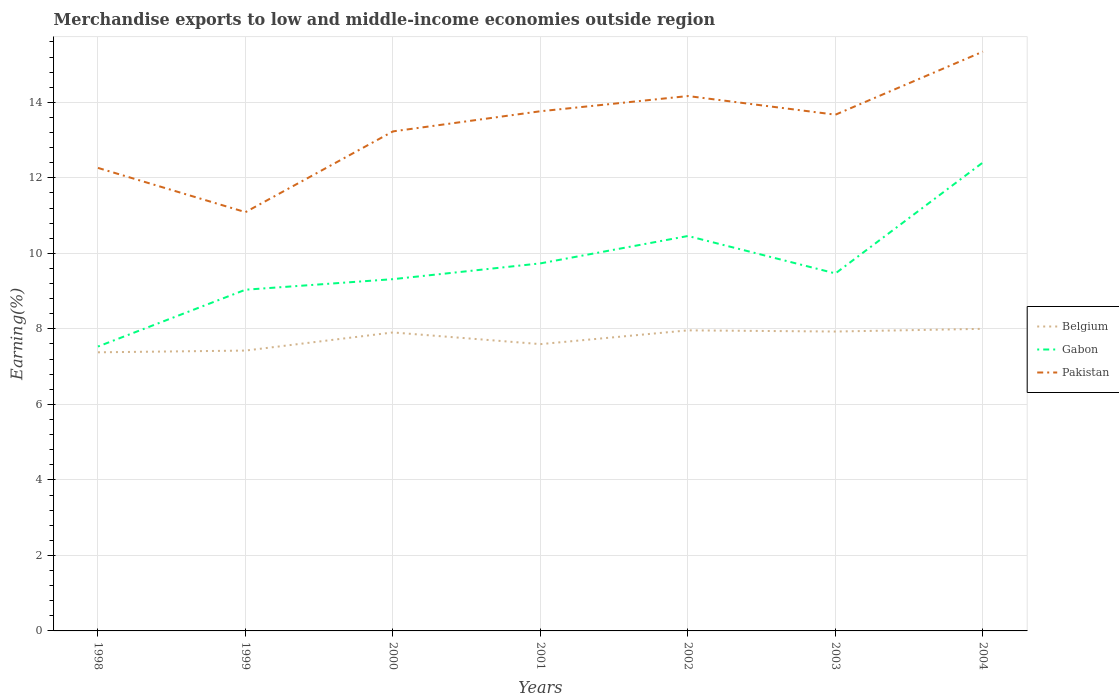Across all years, what is the maximum percentage of amount earned from merchandise exports in Gabon?
Your response must be concise. 7.53. What is the total percentage of amount earned from merchandise exports in Gabon in the graph?
Your response must be concise. -1.5. What is the difference between the highest and the second highest percentage of amount earned from merchandise exports in Belgium?
Your answer should be compact. 0.62. What is the difference between the highest and the lowest percentage of amount earned from merchandise exports in Gabon?
Ensure brevity in your answer.  3. How many lines are there?
Give a very brief answer. 3. What is the difference between two consecutive major ticks on the Y-axis?
Ensure brevity in your answer.  2. Does the graph contain any zero values?
Make the answer very short. No. Does the graph contain grids?
Provide a short and direct response. Yes. Where does the legend appear in the graph?
Provide a succinct answer. Center right. What is the title of the graph?
Keep it short and to the point. Merchandise exports to low and middle-income economies outside region. What is the label or title of the Y-axis?
Offer a terse response. Earning(%). What is the Earning(%) of Belgium in 1998?
Make the answer very short. 7.38. What is the Earning(%) in Gabon in 1998?
Offer a terse response. 7.53. What is the Earning(%) of Pakistan in 1998?
Your response must be concise. 12.26. What is the Earning(%) in Belgium in 1999?
Provide a short and direct response. 7.43. What is the Earning(%) in Gabon in 1999?
Your answer should be compact. 9.04. What is the Earning(%) in Pakistan in 1999?
Offer a terse response. 11.09. What is the Earning(%) in Belgium in 2000?
Make the answer very short. 7.91. What is the Earning(%) in Gabon in 2000?
Provide a short and direct response. 9.32. What is the Earning(%) of Pakistan in 2000?
Keep it short and to the point. 13.23. What is the Earning(%) in Belgium in 2001?
Your response must be concise. 7.6. What is the Earning(%) in Gabon in 2001?
Give a very brief answer. 9.74. What is the Earning(%) of Pakistan in 2001?
Offer a very short reply. 13.76. What is the Earning(%) of Belgium in 2002?
Offer a terse response. 7.96. What is the Earning(%) in Gabon in 2002?
Your answer should be very brief. 10.46. What is the Earning(%) of Pakistan in 2002?
Ensure brevity in your answer.  14.17. What is the Earning(%) of Belgium in 2003?
Your answer should be very brief. 7.93. What is the Earning(%) in Gabon in 2003?
Provide a short and direct response. 9.47. What is the Earning(%) of Pakistan in 2003?
Provide a succinct answer. 13.67. What is the Earning(%) in Belgium in 2004?
Offer a terse response. 8. What is the Earning(%) in Gabon in 2004?
Offer a very short reply. 12.41. What is the Earning(%) of Pakistan in 2004?
Ensure brevity in your answer.  15.34. Across all years, what is the maximum Earning(%) of Belgium?
Provide a succinct answer. 8. Across all years, what is the maximum Earning(%) in Gabon?
Keep it short and to the point. 12.41. Across all years, what is the maximum Earning(%) in Pakistan?
Make the answer very short. 15.34. Across all years, what is the minimum Earning(%) of Belgium?
Offer a terse response. 7.38. Across all years, what is the minimum Earning(%) in Gabon?
Your response must be concise. 7.53. Across all years, what is the minimum Earning(%) of Pakistan?
Your response must be concise. 11.09. What is the total Earning(%) of Belgium in the graph?
Keep it short and to the point. 54.2. What is the total Earning(%) in Gabon in the graph?
Offer a terse response. 67.96. What is the total Earning(%) of Pakistan in the graph?
Keep it short and to the point. 93.54. What is the difference between the Earning(%) in Belgium in 1998 and that in 1999?
Offer a terse response. -0.05. What is the difference between the Earning(%) of Gabon in 1998 and that in 1999?
Keep it short and to the point. -1.5. What is the difference between the Earning(%) in Pakistan in 1998 and that in 1999?
Your answer should be very brief. 1.17. What is the difference between the Earning(%) in Belgium in 1998 and that in 2000?
Give a very brief answer. -0.53. What is the difference between the Earning(%) in Gabon in 1998 and that in 2000?
Offer a very short reply. -1.78. What is the difference between the Earning(%) in Pakistan in 1998 and that in 2000?
Give a very brief answer. -0.97. What is the difference between the Earning(%) in Belgium in 1998 and that in 2001?
Offer a terse response. -0.22. What is the difference between the Earning(%) in Gabon in 1998 and that in 2001?
Offer a terse response. -2.2. What is the difference between the Earning(%) of Pakistan in 1998 and that in 2001?
Offer a terse response. -1.5. What is the difference between the Earning(%) in Belgium in 1998 and that in 2002?
Keep it short and to the point. -0.58. What is the difference between the Earning(%) of Gabon in 1998 and that in 2002?
Your answer should be compact. -2.93. What is the difference between the Earning(%) of Pakistan in 1998 and that in 2002?
Make the answer very short. -1.9. What is the difference between the Earning(%) in Belgium in 1998 and that in 2003?
Give a very brief answer. -0.55. What is the difference between the Earning(%) of Gabon in 1998 and that in 2003?
Give a very brief answer. -1.94. What is the difference between the Earning(%) of Pakistan in 1998 and that in 2003?
Your answer should be very brief. -1.41. What is the difference between the Earning(%) of Belgium in 1998 and that in 2004?
Your answer should be very brief. -0.62. What is the difference between the Earning(%) of Gabon in 1998 and that in 2004?
Provide a short and direct response. -4.88. What is the difference between the Earning(%) of Pakistan in 1998 and that in 2004?
Provide a succinct answer. -3.08. What is the difference between the Earning(%) of Belgium in 1999 and that in 2000?
Make the answer very short. -0.48. What is the difference between the Earning(%) of Gabon in 1999 and that in 2000?
Offer a terse response. -0.28. What is the difference between the Earning(%) in Pakistan in 1999 and that in 2000?
Give a very brief answer. -2.14. What is the difference between the Earning(%) in Belgium in 1999 and that in 2001?
Your response must be concise. -0.17. What is the difference between the Earning(%) of Gabon in 1999 and that in 2001?
Offer a very short reply. -0.7. What is the difference between the Earning(%) in Pakistan in 1999 and that in 2001?
Your answer should be very brief. -2.67. What is the difference between the Earning(%) of Belgium in 1999 and that in 2002?
Offer a very short reply. -0.54. What is the difference between the Earning(%) in Gabon in 1999 and that in 2002?
Your answer should be compact. -1.42. What is the difference between the Earning(%) in Pakistan in 1999 and that in 2002?
Your response must be concise. -3.08. What is the difference between the Earning(%) in Belgium in 1999 and that in 2003?
Provide a short and direct response. -0.5. What is the difference between the Earning(%) in Gabon in 1999 and that in 2003?
Give a very brief answer. -0.43. What is the difference between the Earning(%) of Pakistan in 1999 and that in 2003?
Your answer should be compact. -2.58. What is the difference between the Earning(%) of Belgium in 1999 and that in 2004?
Keep it short and to the point. -0.58. What is the difference between the Earning(%) in Gabon in 1999 and that in 2004?
Ensure brevity in your answer.  -3.37. What is the difference between the Earning(%) of Pakistan in 1999 and that in 2004?
Your answer should be compact. -4.25. What is the difference between the Earning(%) in Belgium in 2000 and that in 2001?
Give a very brief answer. 0.31. What is the difference between the Earning(%) of Gabon in 2000 and that in 2001?
Your answer should be compact. -0.42. What is the difference between the Earning(%) of Pakistan in 2000 and that in 2001?
Make the answer very short. -0.53. What is the difference between the Earning(%) in Belgium in 2000 and that in 2002?
Offer a terse response. -0.06. What is the difference between the Earning(%) of Gabon in 2000 and that in 2002?
Provide a short and direct response. -1.14. What is the difference between the Earning(%) in Pakistan in 2000 and that in 2002?
Your answer should be very brief. -0.94. What is the difference between the Earning(%) of Belgium in 2000 and that in 2003?
Offer a terse response. -0.02. What is the difference between the Earning(%) of Gabon in 2000 and that in 2003?
Provide a succinct answer. -0.15. What is the difference between the Earning(%) of Pakistan in 2000 and that in 2003?
Keep it short and to the point. -0.44. What is the difference between the Earning(%) of Belgium in 2000 and that in 2004?
Your response must be concise. -0.1. What is the difference between the Earning(%) in Gabon in 2000 and that in 2004?
Give a very brief answer. -3.09. What is the difference between the Earning(%) in Pakistan in 2000 and that in 2004?
Make the answer very short. -2.11. What is the difference between the Earning(%) of Belgium in 2001 and that in 2002?
Make the answer very short. -0.36. What is the difference between the Earning(%) of Gabon in 2001 and that in 2002?
Your response must be concise. -0.73. What is the difference between the Earning(%) of Pakistan in 2001 and that in 2002?
Your answer should be compact. -0.4. What is the difference between the Earning(%) of Belgium in 2001 and that in 2003?
Offer a terse response. -0.33. What is the difference between the Earning(%) of Gabon in 2001 and that in 2003?
Provide a succinct answer. 0.27. What is the difference between the Earning(%) in Pakistan in 2001 and that in 2003?
Provide a succinct answer. 0.09. What is the difference between the Earning(%) in Belgium in 2001 and that in 2004?
Provide a succinct answer. -0.41. What is the difference between the Earning(%) in Gabon in 2001 and that in 2004?
Your answer should be very brief. -2.67. What is the difference between the Earning(%) of Pakistan in 2001 and that in 2004?
Make the answer very short. -1.58. What is the difference between the Earning(%) in Belgium in 2002 and that in 2003?
Your response must be concise. 0.03. What is the difference between the Earning(%) of Pakistan in 2002 and that in 2003?
Your answer should be very brief. 0.49. What is the difference between the Earning(%) of Belgium in 2002 and that in 2004?
Provide a short and direct response. -0.04. What is the difference between the Earning(%) of Gabon in 2002 and that in 2004?
Your answer should be very brief. -1.95. What is the difference between the Earning(%) of Pakistan in 2002 and that in 2004?
Provide a short and direct response. -1.18. What is the difference between the Earning(%) in Belgium in 2003 and that in 2004?
Your answer should be very brief. -0.07. What is the difference between the Earning(%) of Gabon in 2003 and that in 2004?
Keep it short and to the point. -2.94. What is the difference between the Earning(%) in Pakistan in 2003 and that in 2004?
Provide a short and direct response. -1.67. What is the difference between the Earning(%) in Belgium in 1998 and the Earning(%) in Gabon in 1999?
Your response must be concise. -1.66. What is the difference between the Earning(%) of Belgium in 1998 and the Earning(%) of Pakistan in 1999?
Your answer should be compact. -3.71. What is the difference between the Earning(%) in Gabon in 1998 and the Earning(%) in Pakistan in 1999?
Provide a short and direct response. -3.56. What is the difference between the Earning(%) in Belgium in 1998 and the Earning(%) in Gabon in 2000?
Provide a succinct answer. -1.94. What is the difference between the Earning(%) of Belgium in 1998 and the Earning(%) of Pakistan in 2000?
Provide a succinct answer. -5.85. What is the difference between the Earning(%) in Gabon in 1998 and the Earning(%) in Pakistan in 2000?
Offer a terse response. -5.7. What is the difference between the Earning(%) of Belgium in 1998 and the Earning(%) of Gabon in 2001?
Make the answer very short. -2.36. What is the difference between the Earning(%) of Belgium in 1998 and the Earning(%) of Pakistan in 2001?
Your response must be concise. -6.38. What is the difference between the Earning(%) of Gabon in 1998 and the Earning(%) of Pakistan in 2001?
Your answer should be very brief. -6.23. What is the difference between the Earning(%) of Belgium in 1998 and the Earning(%) of Gabon in 2002?
Provide a short and direct response. -3.08. What is the difference between the Earning(%) of Belgium in 1998 and the Earning(%) of Pakistan in 2002?
Offer a terse response. -6.79. What is the difference between the Earning(%) in Gabon in 1998 and the Earning(%) in Pakistan in 2002?
Provide a succinct answer. -6.63. What is the difference between the Earning(%) of Belgium in 1998 and the Earning(%) of Gabon in 2003?
Keep it short and to the point. -2.09. What is the difference between the Earning(%) of Belgium in 1998 and the Earning(%) of Pakistan in 2003?
Provide a succinct answer. -6.29. What is the difference between the Earning(%) in Gabon in 1998 and the Earning(%) in Pakistan in 2003?
Offer a very short reply. -6.14. What is the difference between the Earning(%) in Belgium in 1998 and the Earning(%) in Gabon in 2004?
Provide a succinct answer. -5.03. What is the difference between the Earning(%) of Belgium in 1998 and the Earning(%) of Pakistan in 2004?
Your answer should be very brief. -7.96. What is the difference between the Earning(%) of Gabon in 1998 and the Earning(%) of Pakistan in 2004?
Offer a very short reply. -7.81. What is the difference between the Earning(%) in Belgium in 1999 and the Earning(%) in Gabon in 2000?
Give a very brief answer. -1.89. What is the difference between the Earning(%) in Belgium in 1999 and the Earning(%) in Pakistan in 2000?
Give a very brief answer. -5.81. What is the difference between the Earning(%) of Gabon in 1999 and the Earning(%) of Pakistan in 2000?
Your answer should be compact. -4.19. What is the difference between the Earning(%) in Belgium in 1999 and the Earning(%) in Gabon in 2001?
Your response must be concise. -2.31. What is the difference between the Earning(%) of Belgium in 1999 and the Earning(%) of Pakistan in 2001?
Your response must be concise. -6.34. What is the difference between the Earning(%) of Gabon in 1999 and the Earning(%) of Pakistan in 2001?
Offer a terse response. -4.73. What is the difference between the Earning(%) of Belgium in 1999 and the Earning(%) of Gabon in 2002?
Your answer should be compact. -3.04. What is the difference between the Earning(%) in Belgium in 1999 and the Earning(%) in Pakistan in 2002?
Offer a terse response. -6.74. What is the difference between the Earning(%) in Gabon in 1999 and the Earning(%) in Pakistan in 2002?
Your response must be concise. -5.13. What is the difference between the Earning(%) of Belgium in 1999 and the Earning(%) of Gabon in 2003?
Your response must be concise. -2.04. What is the difference between the Earning(%) in Belgium in 1999 and the Earning(%) in Pakistan in 2003?
Ensure brevity in your answer.  -6.25. What is the difference between the Earning(%) of Gabon in 1999 and the Earning(%) of Pakistan in 2003?
Give a very brief answer. -4.64. What is the difference between the Earning(%) of Belgium in 1999 and the Earning(%) of Gabon in 2004?
Provide a short and direct response. -4.98. What is the difference between the Earning(%) in Belgium in 1999 and the Earning(%) in Pakistan in 2004?
Provide a short and direct response. -7.92. What is the difference between the Earning(%) in Gabon in 1999 and the Earning(%) in Pakistan in 2004?
Ensure brevity in your answer.  -6.31. What is the difference between the Earning(%) of Belgium in 2000 and the Earning(%) of Gabon in 2001?
Offer a very short reply. -1.83. What is the difference between the Earning(%) in Belgium in 2000 and the Earning(%) in Pakistan in 2001?
Your answer should be compact. -5.86. What is the difference between the Earning(%) in Gabon in 2000 and the Earning(%) in Pakistan in 2001?
Ensure brevity in your answer.  -4.45. What is the difference between the Earning(%) in Belgium in 2000 and the Earning(%) in Gabon in 2002?
Offer a very short reply. -2.55. What is the difference between the Earning(%) of Belgium in 2000 and the Earning(%) of Pakistan in 2002?
Provide a short and direct response. -6.26. What is the difference between the Earning(%) in Gabon in 2000 and the Earning(%) in Pakistan in 2002?
Your answer should be compact. -4.85. What is the difference between the Earning(%) of Belgium in 2000 and the Earning(%) of Gabon in 2003?
Provide a succinct answer. -1.56. What is the difference between the Earning(%) of Belgium in 2000 and the Earning(%) of Pakistan in 2003?
Ensure brevity in your answer.  -5.77. What is the difference between the Earning(%) of Gabon in 2000 and the Earning(%) of Pakistan in 2003?
Provide a succinct answer. -4.36. What is the difference between the Earning(%) of Belgium in 2000 and the Earning(%) of Gabon in 2004?
Provide a succinct answer. -4.5. What is the difference between the Earning(%) in Belgium in 2000 and the Earning(%) in Pakistan in 2004?
Offer a very short reply. -7.44. What is the difference between the Earning(%) in Gabon in 2000 and the Earning(%) in Pakistan in 2004?
Offer a very short reply. -6.03. What is the difference between the Earning(%) of Belgium in 2001 and the Earning(%) of Gabon in 2002?
Make the answer very short. -2.86. What is the difference between the Earning(%) in Belgium in 2001 and the Earning(%) in Pakistan in 2002?
Provide a short and direct response. -6.57. What is the difference between the Earning(%) of Gabon in 2001 and the Earning(%) of Pakistan in 2002?
Your answer should be very brief. -4.43. What is the difference between the Earning(%) of Belgium in 2001 and the Earning(%) of Gabon in 2003?
Offer a very short reply. -1.87. What is the difference between the Earning(%) in Belgium in 2001 and the Earning(%) in Pakistan in 2003?
Give a very brief answer. -6.08. What is the difference between the Earning(%) in Gabon in 2001 and the Earning(%) in Pakistan in 2003?
Provide a succinct answer. -3.94. What is the difference between the Earning(%) in Belgium in 2001 and the Earning(%) in Gabon in 2004?
Your response must be concise. -4.81. What is the difference between the Earning(%) of Belgium in 2001 and the Earning(%) of Pakistan in 2004?
Make the answer very short. -7.75. What is the difference between the Earning(%) of Gabon in 2001 and the Earning(%) of Pakistan in 2004?
Your answer should be compact. -5.61. What is the difference between the Earning(%) in Belgium in 2002 and the Earning(%) in Gabon in 2003?
Offer a very short reply. -1.51. What is the difference between the Earning(%) of Belgium in 2002 and the Earning(%) of Pakistan in 2003?
Offer a terse response. -5.71. What is the difference between the Earning(%) of Gabon in 2002 and the Earning(%) of Pakistan in 2003?
Give a very brief answer. -3.21. What is the difference between the Earning(%) in Belgium in 2002 and the Earning(%) in Gabon in 2004?
Provide a succinct answer. -4.45. What is the difference between the Earning(%) of Belgium in 2002 and the Earning(%) of Pakistan in 2004?
Give a very brief answer. -7.38. What is the difference between the Earning(%) in Gabon in 2002 and the Earning(%) in Pakistan in 2004?
Offer a terse response. -4.88. What is the difference between the Earning(%) in Belgium in 2003 and the Earning(%) in Gabon in 2004?
Make the answer very short. -4.48. What is the difference between the Earning(%) in Belgium in 2003 and the Earning(%) in Pakistan in 2004?
Offer a terse response. -7.41. What is the difference between the Earning(%) of Gabon in 2003 and the Earning(%) of Pakistan in 2004?
Give a very brief answer. -5.88. What is the average Earning(%) of Belgium per year?
Make the answer very short. 7.74. What is the average Earning(%) of Gabon per year?
Your response must be concise. 9.71. What is the average Earning(%) of Pakistan per year?
Your answer should be very brief. 13.36. In the year 1998, what is the difference between the Earning(%) in Belgium and Earning(%) in Gabon?
Your response must be concise. -0.15. In the year 1998, what is the difference between the Earning(%) in Belgium and Earning(%) in Pakistan?
Your answer should be very brief. -4.88. In the year 1998, what is the difference between the Earning(%) in Gabon and Earning(%) in Pakistan?
Keep it short and to the point. -4.73. In the year 1999, what is the difference between the Earning(%) of Belgium and Earning(%) of Gabon?
Make the answer very short. -1.61. In the year 1999, what is the difference between the Earning(%) in Belgium and Earning(%) in Pakistan?
Give a very brief answer. -3.67. In the year 1999, what is the difference between the Earning(%) of Gabon and Earning(%) of Pakistan?
Offer a very short reply. -2.05. In the year 2000, what is the difference between the Earning(%) of Belgium and Earning(%) of Gabon?
Your response must be concise. -1.41. In the year 2000, what is the difference between the Earning(%) of Belgium and Earning(%) of Pakistan?
Your response must be concise. -5.33. In the year 2000, what is the difference between the Earning(%) of Gabon and Earning(%) of Pakistan?
Give a very brief answer. -3.91. In the year 2001, what is the difference between the Earning(%) in Belgium and Earning(%) in Gabon?
Provide a short and direct response. -2.14. In the year 2001, what is the difference between the Earning(%) in Belgium and Earning(%) in Pakistan?
Make the answer very short. -6.17. In the year 2001, what is the difference between the Earning(%) of Gabon and Earning(%) of Pakistan?
Keep it short and to the point. -4.03. In the year 2002, what is the difference between the Earning(%) of Belgium and Earning(%) of Gabon?
Keep it short and to the point. -2.5. In the year 2002, what is the difference between the Earning(%) in Belgium and Earning(%) in Pakistan?
Your response must be concise. -6.21. In the year 2002, what is the difference between the Earning(%) in Gabon and Earning(%) in Pakistan?
Your response must be concise. -3.71. In the year 2003, what is the difference between the Earning(%) in Belgium and Earning(%) in Gabon?
Offer a very short reply. -1.54. In the year 2003, what is the difference between the Earning(%) in Belgium and Earning(%) in Pakistan?
Your answer should be very brief. -5.74. In the year 2003, what is the difference between the Earning(%) of Gabon and Earning(%) of Pakistan?
Offer a very short reply. -4.2. In the year 2004, what is the difference between the Earning(%) of Belgium and Earning(%) of Gabon?
Make the answer very short. -4.41. In the year 2004, what is the difference between the Earning(%) of Belgium and Earning(%) of Pakistan?
Your answer should be very brief. -7.34. In the year 2004, what is the difference between the Earning(%) in Gabon and Earning(%) in Pakistan?
Provide a succinct answer. -2.94. What is the ratio of the Earning(%) of Gabon in 1998 to that in 1999?
Keep it short and to the point. 0.83. What is the ratio of the Earning(%) of Pakistan in 1998 to that in 1999?
Your response must be concise. 1.11. What is the ratio of the Earning(%) of Belgium in 1998 to that in 2000?
Provide a short and direct response. 0.93. What is the ratio of the Earning(%) of Gabon in 1998 to that in 2000?
Provide a short and direct response. 0.81. What is the ratio of the Earning(%) of Pakistan in 1998 to that in 2000?
Offer a very short reply. 0.93. What is the ratio of the Earning(%) of Belgium in 1998 to that in 2001?
Your response must be concise. 0.97. What is the ratio of the Earning(%) in Gabon in 1998 to that in 2001?
Give a very brief answer. 0.77. What is the ratio of the Earning(%) of Pakistan in 1998 to that in 2001?
Make the answer very short. 0.89. What is the ratio of the Earning(%) of Belgium in 1998 to that in 2002?
Offer a very short reply. 0.93. What is the ratio of the Earning(%) of Gabon in 1998 to that in 2002?
Offer a terse response. 0.72. What is the ratio of the Earning(%) of Pakistan in 1998 to that in 2002?
Make the answer very short. 0.87. What is the ratio of the Earning(%) in Belgium in 1998 to that in 2003?
Provide a short and direct response. 0.93. What is the ratio of the Earning(%) of Gabon in 1998 to that in 2003?
Provide a short and direct response. 0.8. What is the ratio of the Earning(%) of Pakistan in 1998 to that in 2003?
Your answer should be compact. 0.9. What is the ratio of the Earning(%) in Belgium in 1998 to that in 2004?
Offer a very short reply. 0.92. What is the ratio of the Earning(%) of Gabon in 1998 to that in 2004?
Your response must be concise. 0.61. What is the ratio of the Earning(%) of Pakistan in 1998 to that in 2004?
Make the answer very short. 0.8. What is the ratio of the Earning(%) of Belgium in 1999 to that in 2000?
Provide a succinct answer. 0.94. What is the ratio of the Earning(%) of Gabon in 1999 to that in 2000?
Provide a succinct answer. 0.97. What is the ratio of the Earning(%) of Pakistan in 1999 to that in 2000?
Your response must be concise. 0.84. What is the ratio of the Earning(%) in Belgium in 1999 to that in 2001?
Keep it short and to the point. 0.98. What is the ratio of the Earning(%) of Gabon in 1999 to that in 2001?
Your answer should be compact. 0.93. What is the ratio of the Earning(%) in Pakistan in 1999 to that in 2001?
Your answer should be very brief. 0.81. What is the ratio of the Earning(%) in Belgium in 1999 to that in 2002?
Your answer should be very brief. 0.93. What is the ratio of the Earning(%) in Gabon in 1999 to that in 2002?
Your answer should be compact. 0.86. What is the ratio of the Earning(%) in Pakistan in 1999 to that in 2002?
Provide a short and direct response. 0.78. What is the ratio of the Earning(%) of Belgium in 1999 to that in 2003?
Your response must be concise. 0.94. What is the ratio of the Earning(%) in Gabon in 1999 to that in 2003?
Ensure brevity in your answer.  0.95. What is the ratio of the Earning(%) of Pakistan in 1999 to that in 2003?
Give a very brief answer. 0.81. What is the ratio of the Earning(%) in Belgium in 1999 to that in 2004?
Provide a succinct answer. 0.93. What is the ratio of the Earning(%) of Gabon in 1999 to that in 2004?
Your answer should be very brief. 0.73. What is the ratio of the Earning(%) in Pakistan in 1999 to that in 2004?
Your response must be concise. 0.72. What is the ratio of the Earning(%) in Belgium in 2000 to that in 2001?
Your response must be concise. 1.04. What is the ratio of the Earning(%) of Gabon in 2000 to that in 2001?
Keep it short and to the point. 0.96. What is the ratio of the Earning(%) in Pakistan in 2000 to that in 2001?
Offer a very short reply. 0.96. What is the ratio of the Earning(%) of Gabon in 2000 to that in 2002?
Provide a succinct answer. 0.89. What is the ratio of the Earning(%) of Pakistan in 2000 to that in 2002?
Keep it short and to the point. 0.93. What is the ratio of the Earning(%) in Gabon in 2000 to that in 2003?
Offer a very short reply. 0.98. What is the ratio of the Earning(%) in Pakistan in 2000 to that in 2003?
Ensure brevity in your answer.  0.97. What is the ratio of the Earning(%) in Gabon in 2000 to that in 2004?
Your response must be concise. 0.75. What is the ratio of the Earning(%) of Pakistan in 2000 to that in 2004?
Provide a short and direct response. 0.86. What is the ratio of the Earning(%) of Belgium in 2001 to that in 2002?
Your response must be concise. 0.95. What is the ratio of the Earning(%) of Gabon in 2001 to that in 2002?
Provide a short and direct response. 0.93. What is the ratio of the Earning(%) in Pakistan in 2001 to that in 2002?
Provide a short and direct response. 0.97. What is the ratio of the Earning(%) of Belgium in 2001 to that in 2003?
Give a very brief answer. 0.96. What is the ratio of the Earning(%) of Gabon in 2001 to that in 2003?
Make the answer very short. 1.03. What is the ratio of the Earning(%) in Pakistan in 2001 to that in 2003?
Your response must be concise. 1.01. What is the ratio of the Earning(%) in Belgium in 2001 to that in 2004?
Offer a terse response. 0.95. What is the ratio of the Earning(%) of Gabon in 2001 to that in 2004?
Provide a short and direct response. 0.78. What is the ratio of the Earning(%) in Pakistan in 2001 to that in 2004?
Keep it short and to the point. 0.9. What is the ratio of the Earning(%) in Gabon in 2002 to that in 2003?
Provide a succinct answer. 1.1. What is the ratio of the Earning(%) of Pakistan in 2002 to that in 2003?
Your answer should be compact. 1.04. What is the ratio of the Earning(%) of Gabon in 2002 to that in 2004?
Provide a short and direct response. 0.84. What is the ratio of the Earning(%) of Pakistan in 2002 to that in 2004?
Offer a very short reply. 0.92. What is the ratio of the Earning(%) in Belgium in 2003 to that in 2004?
Your answer should be compact. 0.99. What is the ratio of the Earning(%) of Gabon in 2003 to that in 2004?
Your answer should be compact. 0.76. What is the ratio of the Earning(%) of Pakistan in 2003 to that in 2004?
Offer a terse response. 0.89. What is the difference between the highest and the second highest Earning(%) of Belgium?
Your response must be concise. 0.04. What is the difference between the highest and the second highest Earning(%) in Gabon?
Keep it short and to the point. 1.95. What is the difference between the highest and the second highest Earning(%) of Pakistan?
Keep it short and to the point. 1.18. What is the difference between the highest and the lowest Earning(%) of Belgium?
Ensure brevity in your answer.  0.62. What is the difference between the highest and the lowest Earning(%) in Gabon?
Provide a succinct answer. 4.88. What is the difference between the highest and the lowest Earning(%) in Pakistan?
Your answer should be compact. 4.25. 